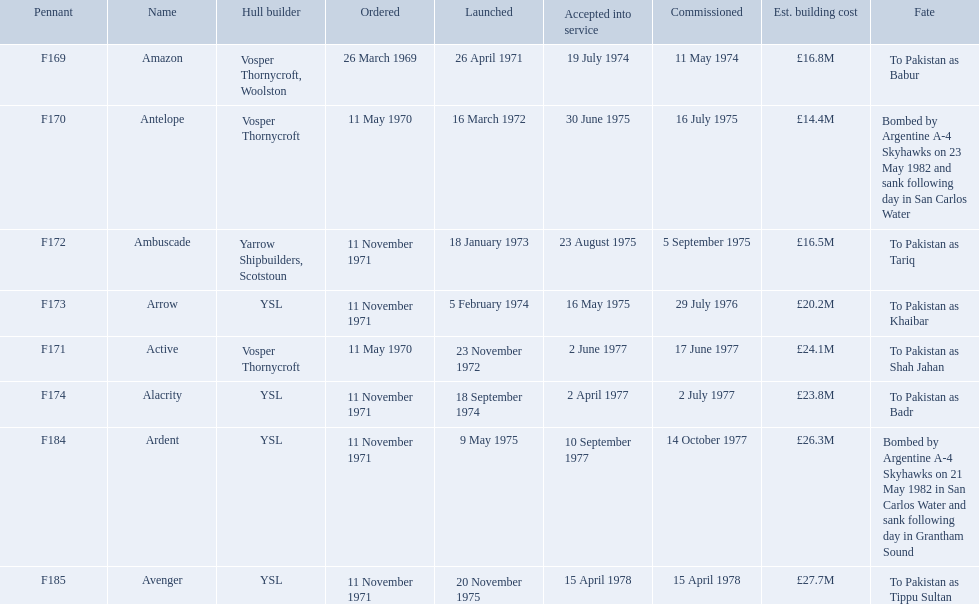What were the estimated building costs of the frigates? £16.8M, £14.4M, £16.5M, £20.2M, £24.1M, £23.8M, £26.3M, £27.7M. Which of these is the largest? £27.7M. What ship name does that correspond to? Avenger. 